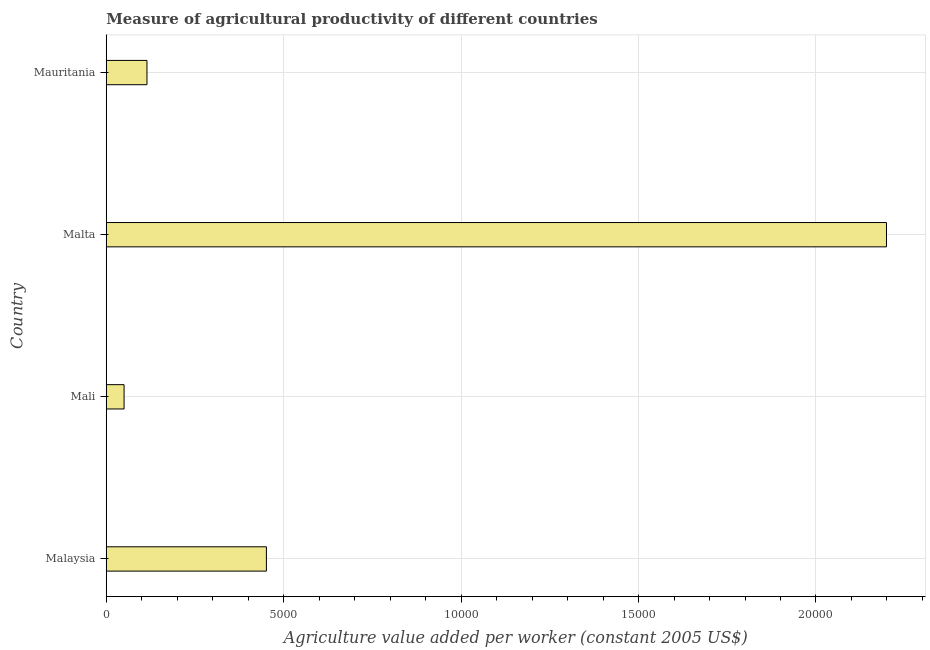What is the title of the graph?
Your answer should be compact. Measure of agricultural productivity of different countries. What is the label or title of the X-axis?
Ensure brevity in your answer.  Agriculture value added per worker (constant 2005 US$). What is the agriculture value added per worker in Malaysia?
Ensure brevity in your answer.  4513.17. Across all countries, what is the maximum agriculture value added per worker?
Ensure brevity in your answer.  2.20e+04. Across all countries, what is the minimum agriculture value added per worker?
Provide a short and direct response. 502.28. In which country was the agriculture value added per worker maximum?
Ensure brevity in your answer.  Malta. In which country was the agriculture value added per worker minimum?
Make the answer very short. Mali. What is the sum of the agriculture value added per worker?
Provide a short and direct response. 2.81e+04. What is the difference between the agriculture value added per worker in Malaysia and Mauritania?
Make the answer very short. 3365.76. What is the average agriculture value added per worker per country?
Make the answer very short. 7037.47. What is the median agriculture value added per worker?
Provide a succinct answer. 2830.28. What is the ratio of the agriculture value added per worker in Malaysia to that in Mali?
Keep it short and to the point. 8.98. Is the difference between the agriculture value added per worker in Mali and Mauritania greater than the difference between any two countries?
Provide a short and direct response. No. What is the difference between the highest and the second highest agriculture value added per worker?
Keep it short and to the point. 1.75e+04. Is the sum of the agriculture value added per worker in Malta and Mauritania greater than the maximum agriculture value added per worker across all countries?
Your answer should be very brief. Yes. What is the difference between the highest and the lowest agriculture value added per worker?
Provide a succinct answer. 2.15e+04. In how many countries, is the agriculture value added per worker greater than the average agriculture value added per worker taken over all countries?
Offer a terse response. 1. How many countries are there in the graph?
Your answer should be very brief. 4. What is the difference between two consecutive major ticks on the X-axis?
Provide a short and direct response. 5000. Are the values on the major ticks of X-axis written in scientific E-notation?
Provide a succinct answer. No. What is the Agriculture value added per worker (constant 2005 US$) of Malaysia?
Make the answer very short. 4513.17. What is the Agriculture value added per worker (constant 2005 US$) in Mali?
Give a very brief answer. 502.28. What is the Agriculture value added per worker (constant 2005 US$) of Malta?
Your response must be concise. 2.20e+04. What is the Agriculture value added per worker (constant 2005 US$) in Mauritania?
Ensure brevity in your answer.  1147.4. What is the difference between the Agriculture value added per worker (constant 2005 US$) in Malaysia and Mali?
Keep it short and to the point. 4010.88. What is the difference between the Agriculture value added per worker (constant 2005 US$) in Malaysia and Malta?
Make the answer very short. -1.75e+04. What is the difference between the Agriculture value added per worker (constant 2005 US$) in Malaysia and Mauritania?
Your answer should be compact. 3365.76. What is the difference between the Agriculture value added per worker (constant 2005 US$) in Mali and Malta?
Your answer should be compact. -2.15e+04. What is the difference between the Agriculture value added per worker (constant 2005 US$) in Mali and Mauritania?
Your answer should be compact. -645.12. What is the difference between the Agriculture value added per worker (constant 2005 US$) in Malta and Mauritania?
Make the answer very short. 2.08e+04. What is the ratio of the Agriculture value added per worker (constant 2005 US$) in Malaysia to that in Mali?
Give a very brief answer. 8.98. What is the ratio of the Agriculture value added per worker (constant 2005 US$) in Malaysia to that in Malta?
Keep it short and to the point. 0.2. What is the ratio of the Agriculture value added per worker (constant 2005 US$) in Malaysia to that in Mauritania?
Provide a short and direct response. 3.93. What is the ratio of the Agriculture value added per worker (constant 2005 US$) in Mali to that in Malta?
Your response must be concise. 0.02. What is the ratio of the Agriculture value added per worker (constant 2005 US$) in Mali to that in Mauritania?
Your answer should be very brief. 0.44. What is the ratio of the Agriculture value added per worker (constant 2005 US$) in Malta to that in Mauritania?
Provide a short and direct response. 19.16. 